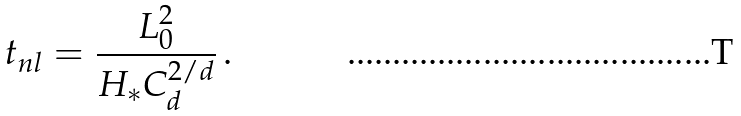<formula> <loc_0><loc_0><loc_500><loc_500>t _ { n l } = \frac { L _ { 0 } ^ { 2 } } { H _ { * } C _ { d } ^ { 2 / d } } \, .</formula> 